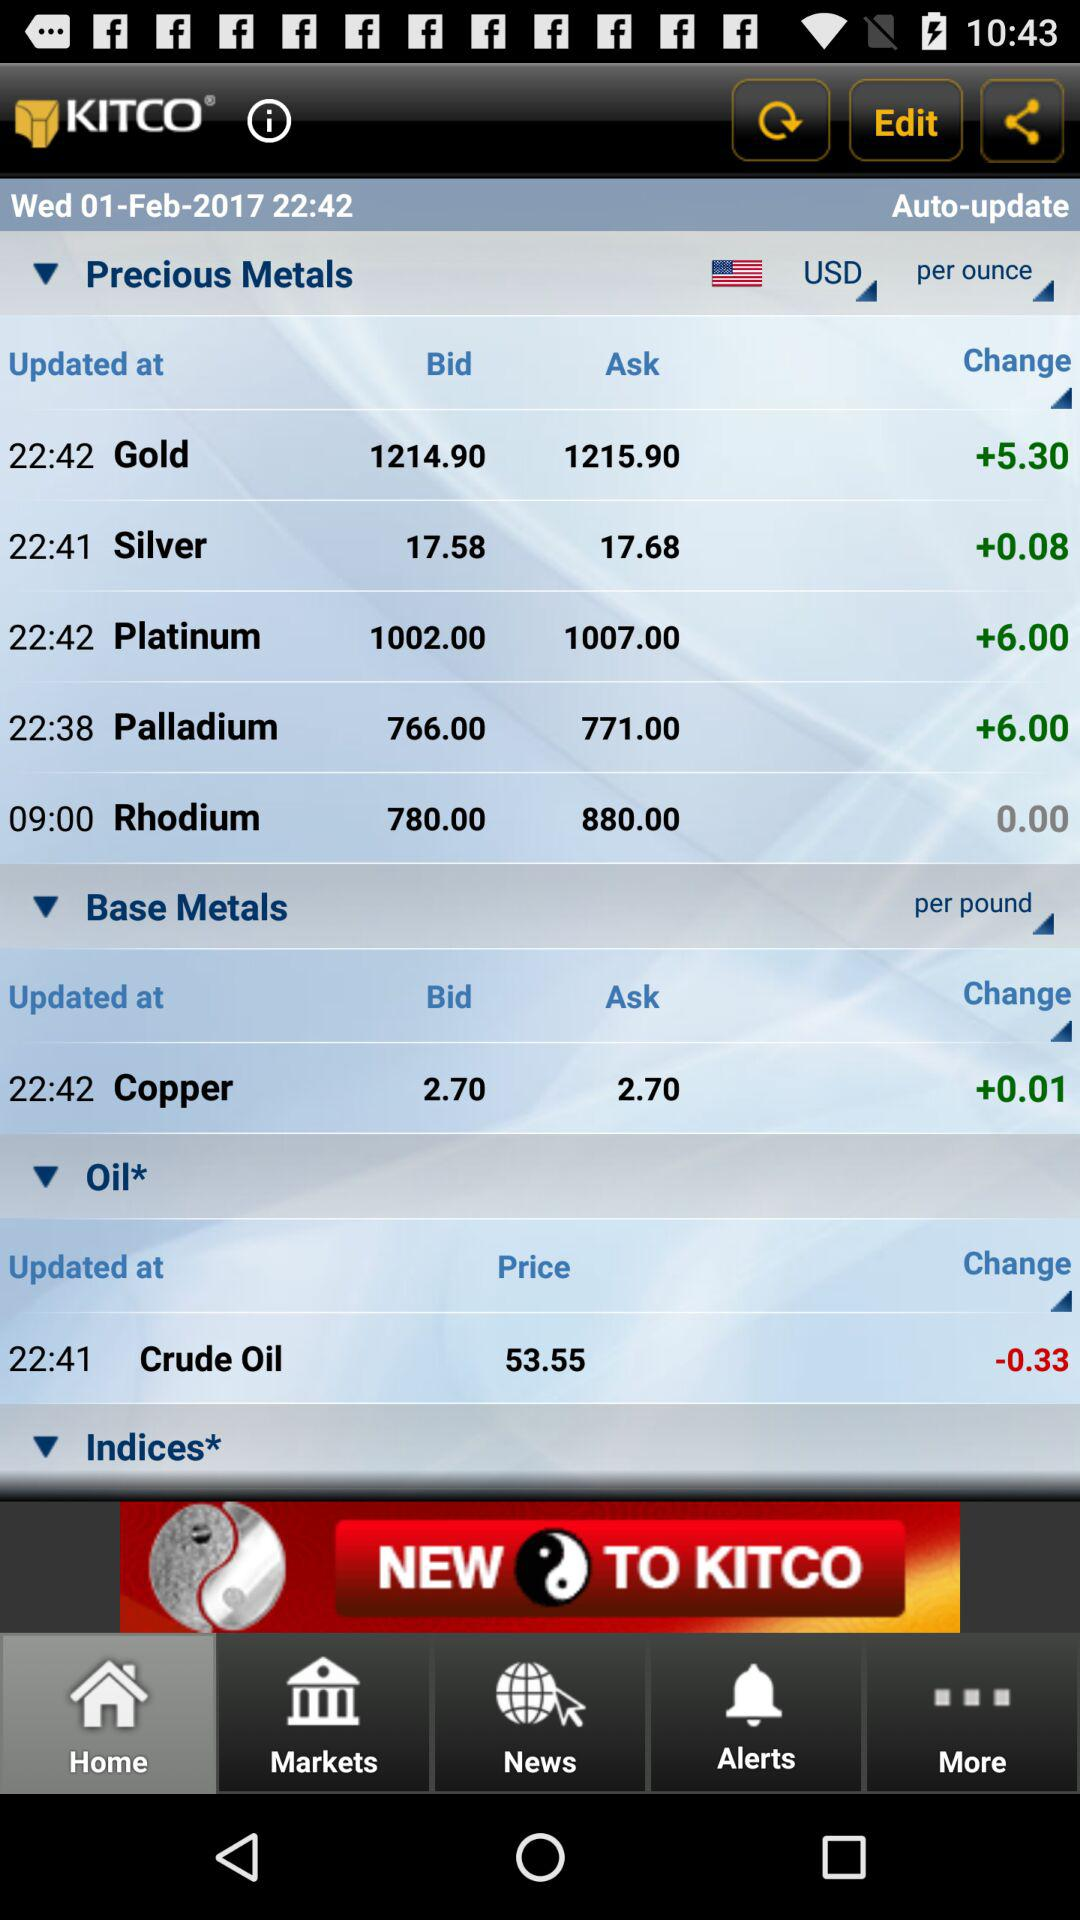What is the bid price of "Silver"? The bid price of "Silver" is 17.58 USD per ounce. 